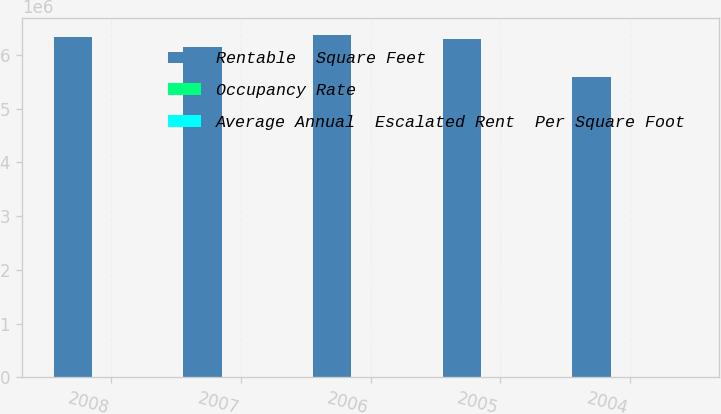Convert chart to OTSL. <chart><loc_0><loc_0><loc_500><loc_500><stacked_bar_chart><ecel><fcel>2008<fcel>2007<fcel>2006<fcel>2005<fcel>2004<nl><fcel>Rentable  Square Feet<fcel>6.332e+06<fcel>6.139e+06<fcel>6.37e+06<fcel>6.29e+06<fcel>5.589e+06<nl><fcel>Occupancy Rate<fcel>92.2<fcel>93.7<fcel>93.6<fcel>94.7<fcel>97.6<nl><fcel>Average Annual  Escalated Rent  Per Square Foot<fcel>26.72<fcel>26.16<fcel>25.17<fcel>24.04<fcel>23.08<nl></chart> 